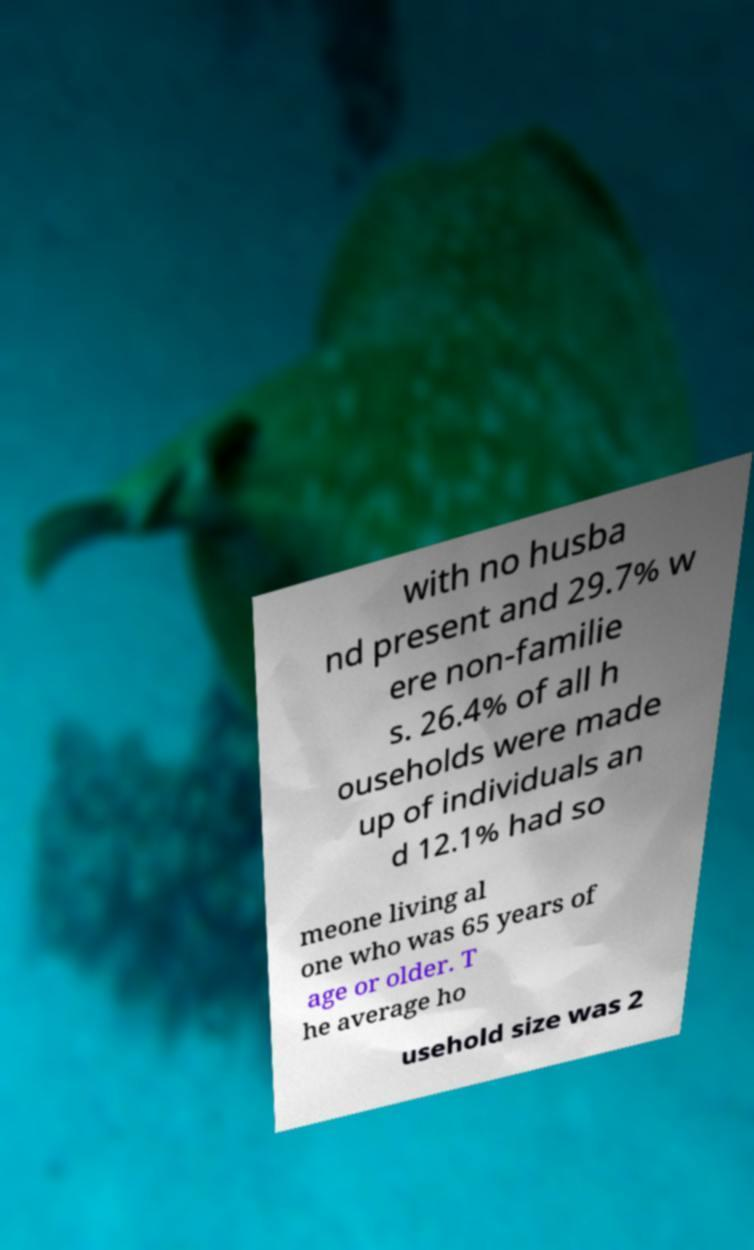There's text embedded in this image that I need extracted. Can you transcribe it verbatim? with no husba nd present and 29.7% w ere non-familie s. 26.4% of all h ouseholds were made up of individuals an d 12.1% had so meone living al one who was 65 years of age or older. T he average ho usehold size was 2 